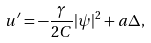<formula> <loc_0><loc_0><loc_500><loc_500>u ^ { \prime } = - \frac { \gamma } { 2 C } | \psi | ^ { 2 } + a \Delta ,</formula> 